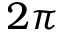Convert formula to latex. <formula><loc_0><loc_0><loc_500><loc_500>2 \pi</formula> 